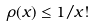Convert formula to latex. <formula><loc_0><loc_0><loc_500><loc_500>\rho ( x ) \leq 1 / x !</formula> 